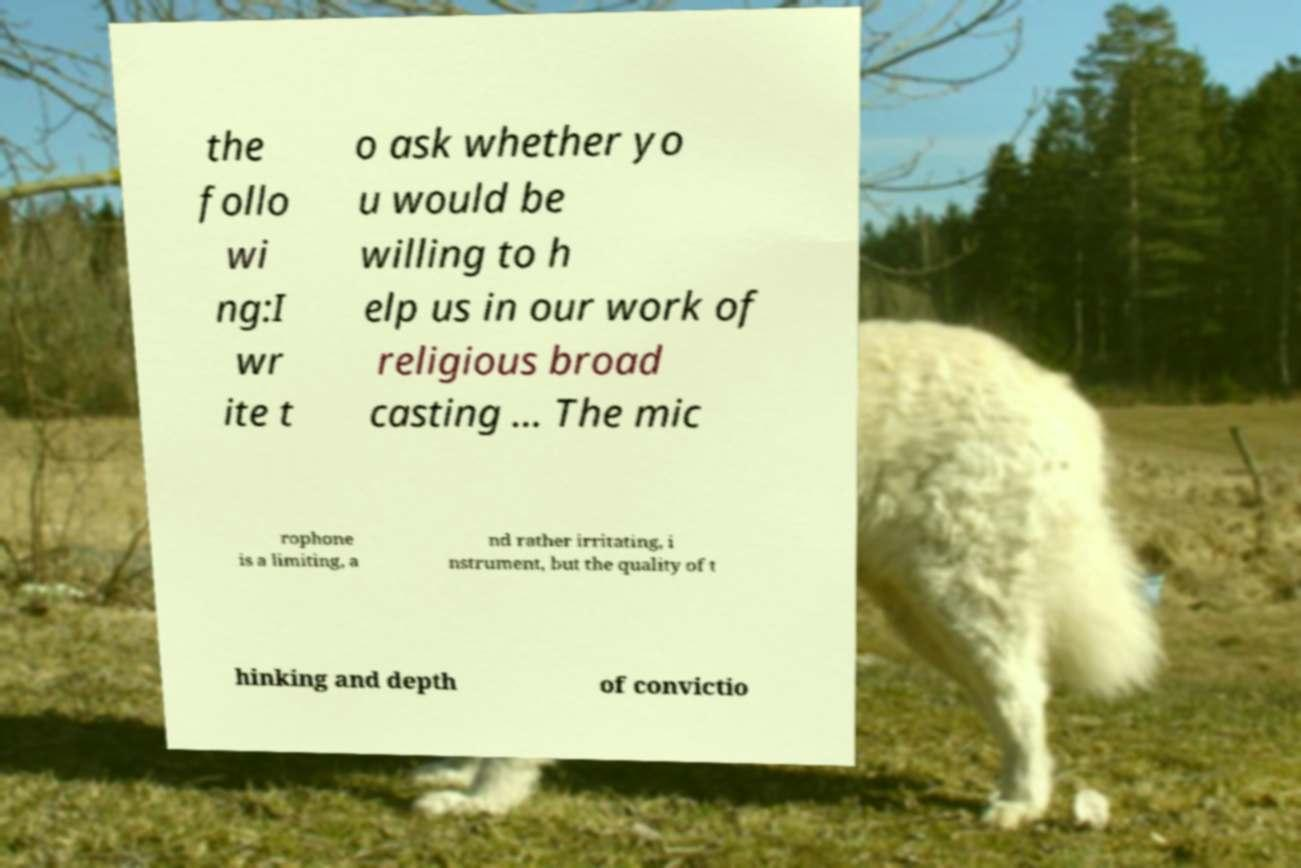I need the written content from this picture converted into text. Can you do that? the follo wi ng:I wr ite t o ask whether yo u would be willing to h elp us in our work of religious broad casting ... The mic rophone is a limiting, a nd rather irritating, i nstrument, but the quality of t hinking and depth of convictio 